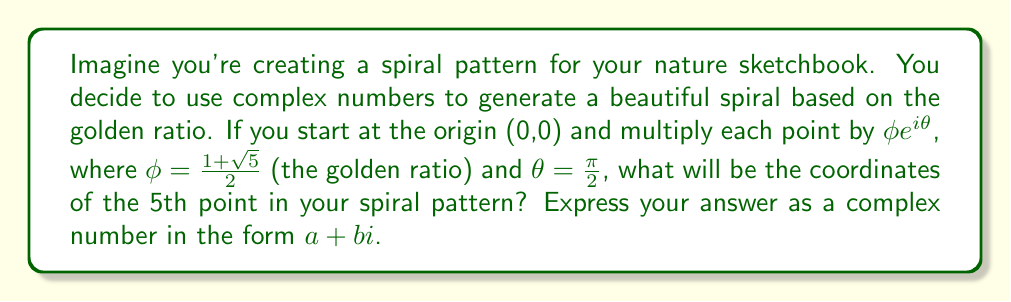Solve this math problem. Let's approach this step-by-step:

1) First, recall that multiplying by a complex number in polar form $re^{i\theta}$ rotates a point by angle $\theta$ and scales it by factor $r$.

2) In this case, $r = \phi = \frac{1+\sqrt{5}}{2} \approx 1.618$ (the golden ratio)
   and $\theta = \frac{\pi}{2}$ (90 degrees)

3) The complex number we're multiplying by at each step is:
   $$\phi e^{i\frac{\pi}{2}} = \phi (\cos \frac{\pi}{2} + i \sin \frac{\pi}{2}) = \phi i$$

4) Starting at the origin (0,0), let's calculate each point:
   
   Point 1: $0 \cdot \phi i = 0$
   Point 2: $0 \cdot \phi i = 0$
   Point 3: $0 \cdot \phi i = 0$
   Point 4: $0 \cdot \phi i = 0$
   Point 5: $0 \cdot \phi i = 0$

5) We see that multiplying by $\phi i$ doesn't move us from the origin. To create a spiral, we need to add $\phi i$ at each step instead of multiplying:

   Point 1: $0 + \phi i = \phi i$
   Point 2: $\phi i + \phi i = 2\phi i$
   Point 3: $2\phi i + \phi i = 3\phi i$
   Point 4: $3\phi i + \phi i = 4\phi i$
   Point 5: $4\phi i + \phi i = 5\phi i$

6) The 5th point is $5\phi i$. Substituting the value of $\phi$:

   $$5 \cdot \frac{1+\sqrt{5}}{2} i = \frac{5+5\sqrt{5}}{2} i$$
Answer: $\frac{5+5\sqrt{5}}{2}i$ or approximately $0+8.09i$ 